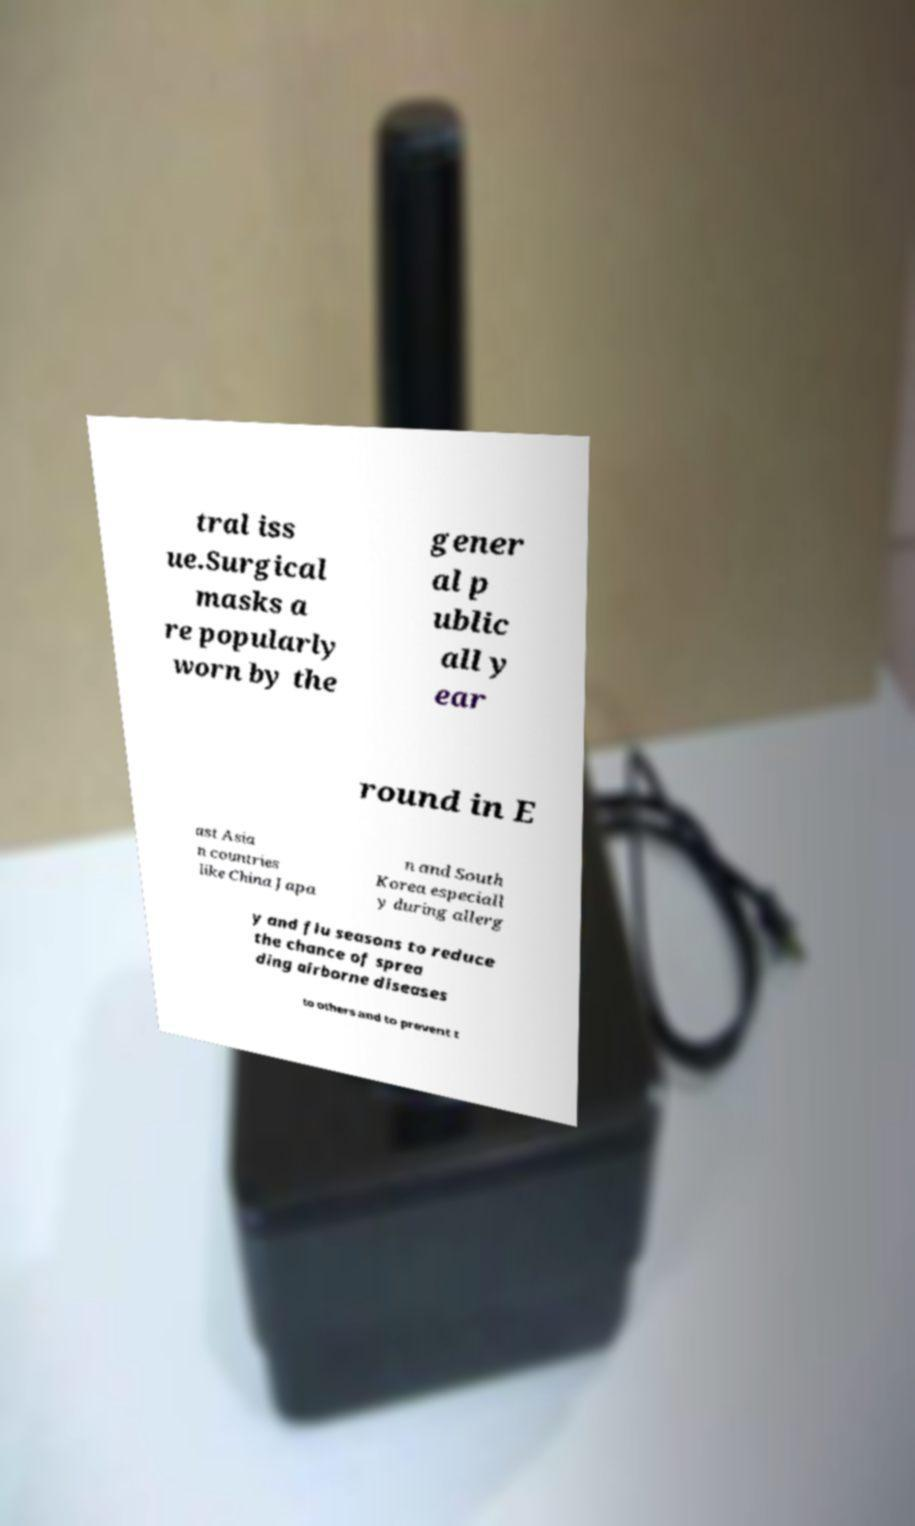Could you extract and type out the text from this image? tral iss ue.Surgical masks a re popularly worn by the gener al p ublic all y ear round in E ast Asia n countries like China Japa n and South Korea especiall y during allerg y and flu seasons to reduce the chance of sprea ding airborne diseases to others and to prevent t 